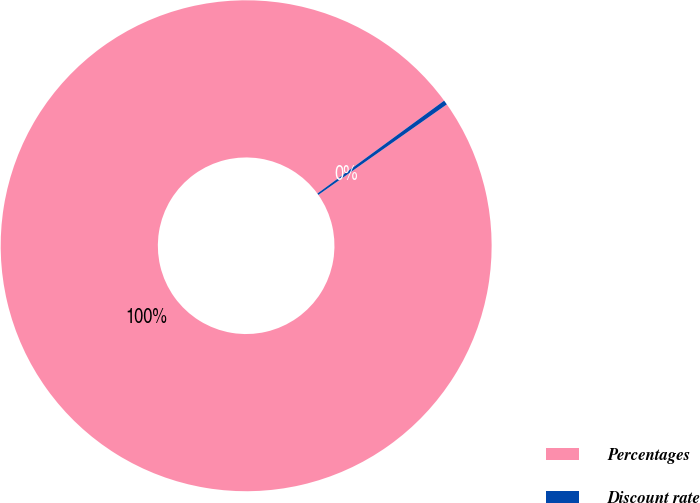Convert chart. <chart><loc_0><loc_0><loc_500><loc_500><pie_chart><fcel>Percentages<fcel>Discount rate<nl><fcel>99.7%<fcel>0.3%<nl></chart> 